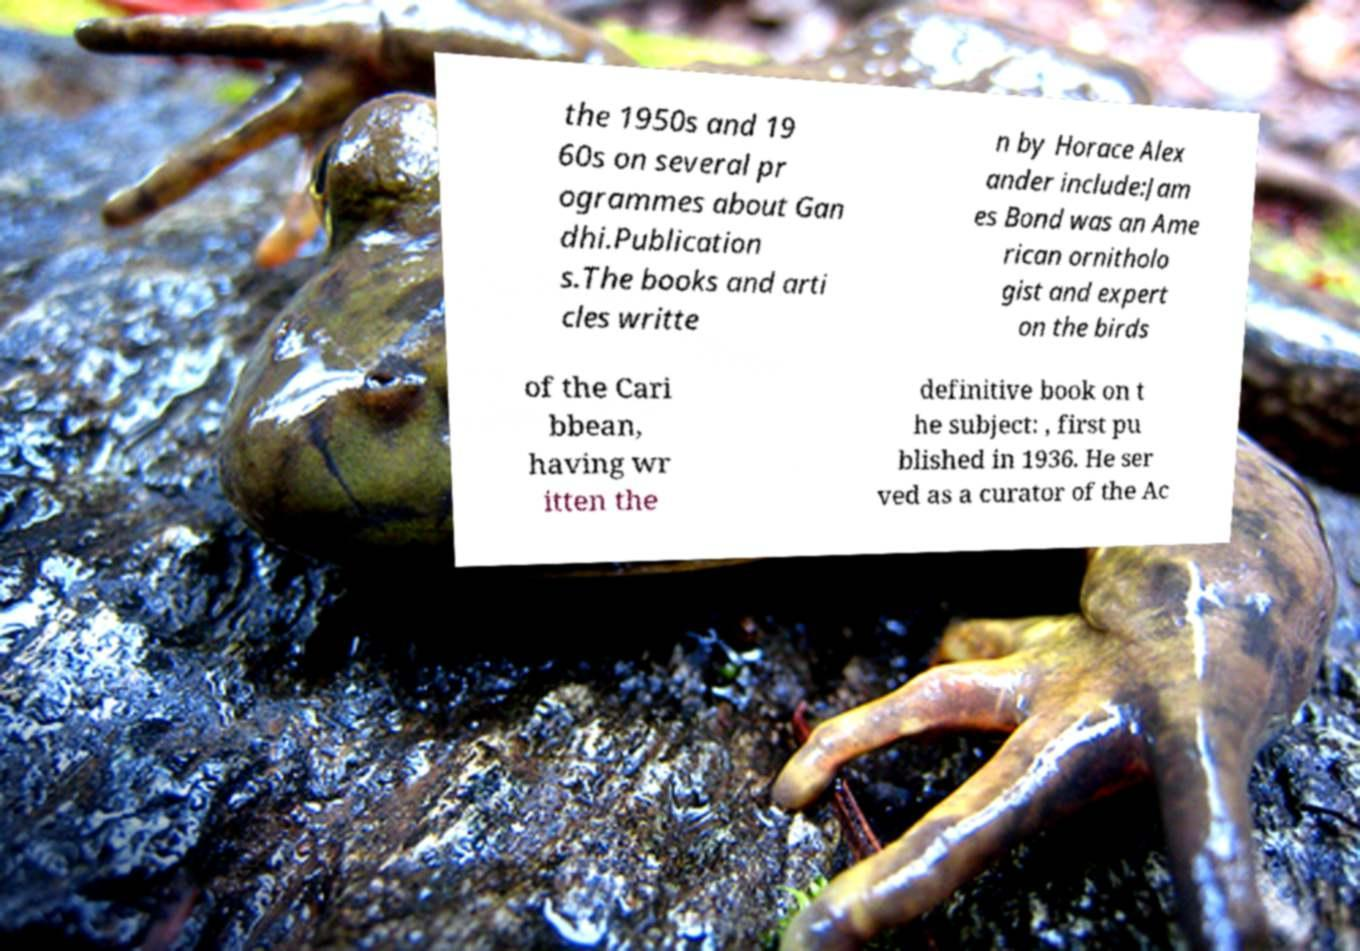Could you extract and type out the text from this image? the 1950s and 19 60s on several pr ogrammes about Gan dhi.Publication s.The books and arti cles writte n by Horace Alex ander include:Jam es Bond was an Ame rican ornitholo gist and expert on the birds of the Cari bbean, having wr itten the definitive book on t he subject: , first pu blished in 1936. He ser ved as a curator of the Ac 